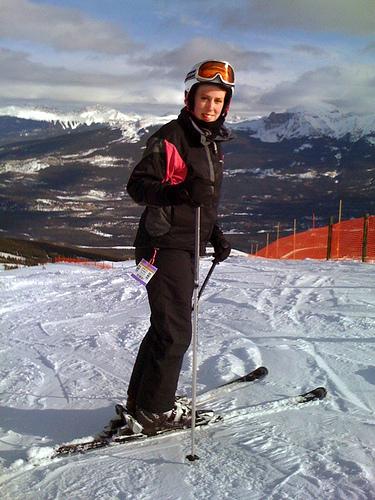Does this person have glasses?
Concise answer only. No. How many mountains are in the background?
Be succinct. 2. Is the skier looking at the camera?
Answer briefly. Yes. During what season was this photo taken?
Quick response, please. Winter. Is that a phone in his hand?
Short answer required. No. Is the woman wearing a backpack?
Be succinct. No. What is the man doing?
Be succinct. Skiing. What is covering the mountain?
Give a very brief answer. Snow. 